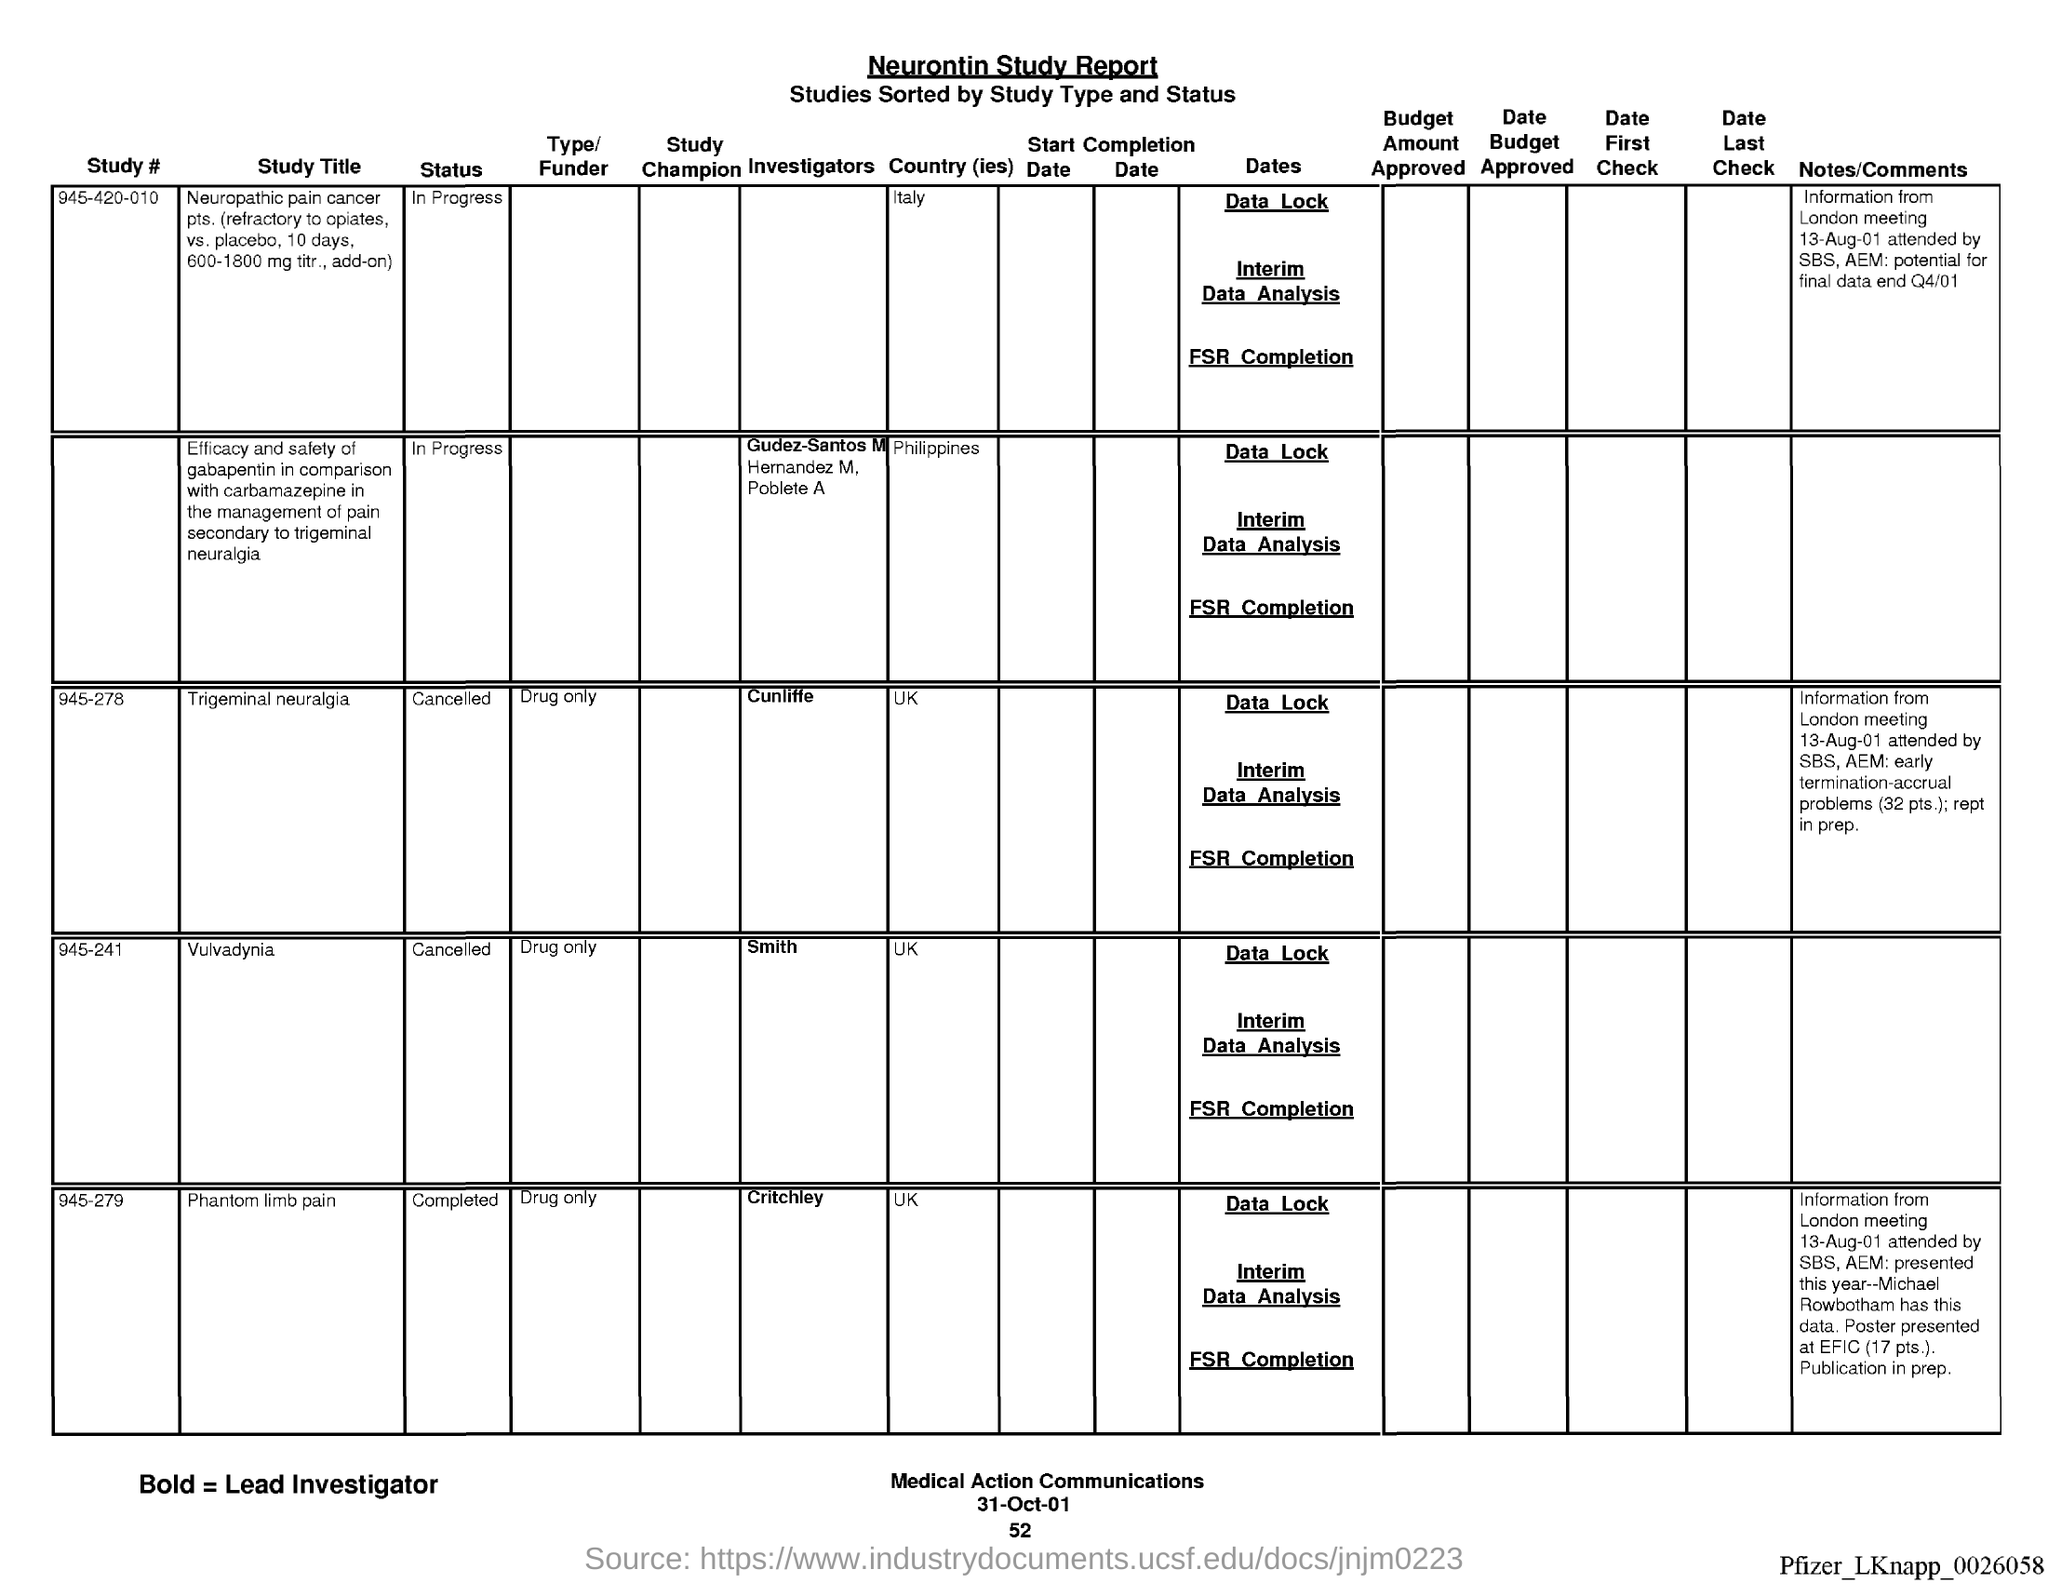What is the status of study # 945-420-010?
Your answer should be compact. In progress. When was the london meeting held?
Keep it short and to the point. 13-Aug-01. What is the type/funder for study # 945-278?
Make the answer very short. Drug only. What country is mentioned for study # 945-278?
Make the answer very short. UK. What is the date mentioned at the bottom of the document?
Keep it short and to the point. 31-Oct-01. 